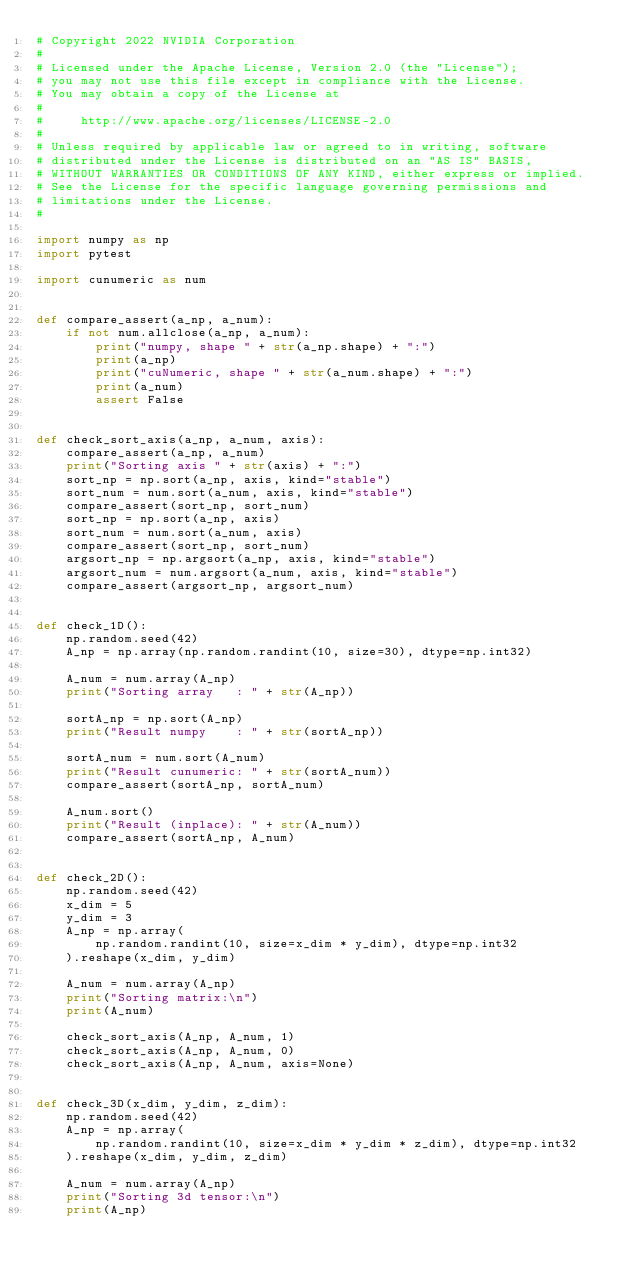<code> <loc_0><loc_0><loc_500><loc_500><_Python_># Copyright 2022 NVIDIA Corporation
#
# Licensed under the Apache License, Version 2.0 (the "License");
# you may not use this file except in compliance with the License.
# You may obtain a copy of the License at
#
#     http://www.apache.org/licenses/LICENSE-2.0
#
# Unless required by applicable law or agreed to in writing, software
# distributed under the License is distributed on an "AS IS" BASIS,
# WITHOUT WARRANTIES OR CONDITIONS OF ANY KIND, either express or implied.
# See the License for the specific language governing permissions and
# limitations under the License.
#

import numpy as np
import pytest

import cunumeric as num


def compare_assert(a_np, a_num):
    if not num.allclose(a_np, a_num):
        print("numpy, shape " + str(a_np.shape) + ":")
        print(a_np)
        print("cuNumeric, shape " + str(a_num.shape) + ":")
        print(a_num)
        assert False


def check_sort_axis(a_np, a_num, axis):
    compare_assert(a_np, a_num)
    print("Sorting axis " + str(axis) + ":")
    sort_np = np.sort(a_np, axis, kind="stable")
    sort_num = num.sort(a_num, axis, kind="stable")
    compare_assert(sort_np, sort_num)
    sort_np = np.sort(a_np, axis)
    sort_num = num.sort(a_num, axis)
    compare_assert(sort_np, sort_num)
    argsort_np = np.argsort(a_np, axis, kind="stable")
    argsort_num = num.argsort(a_num, axis, kind="stable")
    compare_assert(argsort_np, argsort_num)


def check_1D():
    np.random.seed(42)
    A_np = np.array(np.random.randint(10, size=30), dtype=np.int32)

    A_num = num.array(A_np)
    print("Sorting array   : " + str(A_np))

    sortA_np = np.sort(A_np)
    print("Result numpy    : " + str(sortA_np))

    sortA_num = num.sort(A_num)
    print("Result cunumeric: " + str(sortA_num))
    compare_assert(sortA_np, sortA_num)

    A_num.sort()
    print("Result (inplace): " + str(A_num))
    compare_assert(sortA_np, A_num)


def check_2D():
    np.random.seed(42)
    x_dim = 5
    y_dim = 3
    A_np = np.array(
        np.random.randint(10, size=x_dim * y_dim), dtype=np.int32
    ).reshape(x_dim, y_dim)

    A_num = num.array(A_np)
    print("Sorting matrix:\n")
    print(A_num)

    check_sort_axis(A_np, A_num, 1)
    check_sort_axis(A_np, A_num, 0)
    check_sort_axis(A_np, A_num, axis=None)


def check_3D(x_dim, y_dim, z_dim):
    np.random.seed(42)
    A_np = np.array(
        np.random.randint(10, size=x_dim * y_dim * z_dim), dtype=np.int32
    ).reshape(x_dim, y_dim, z_dim)

    A_num = num.array(A_np)
    print("Sorting 3d tensor:\n")
    print(A_np)
</code> 